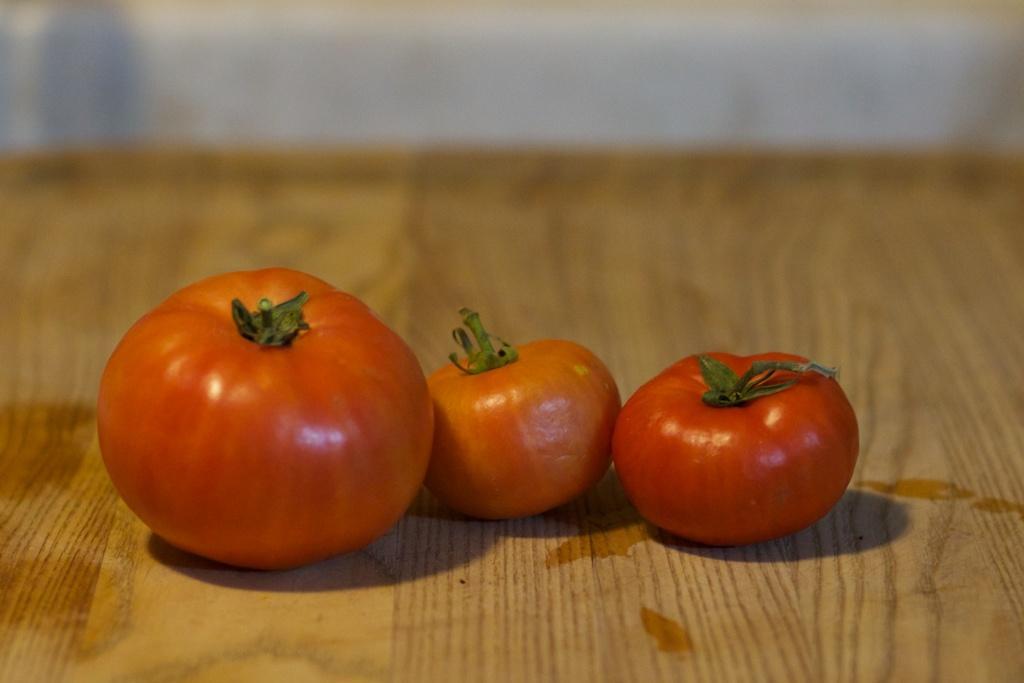In one or two sentences, can you explain what this image depicts? There are three tomatoes on a wooden surface. In the background it is blurred. 